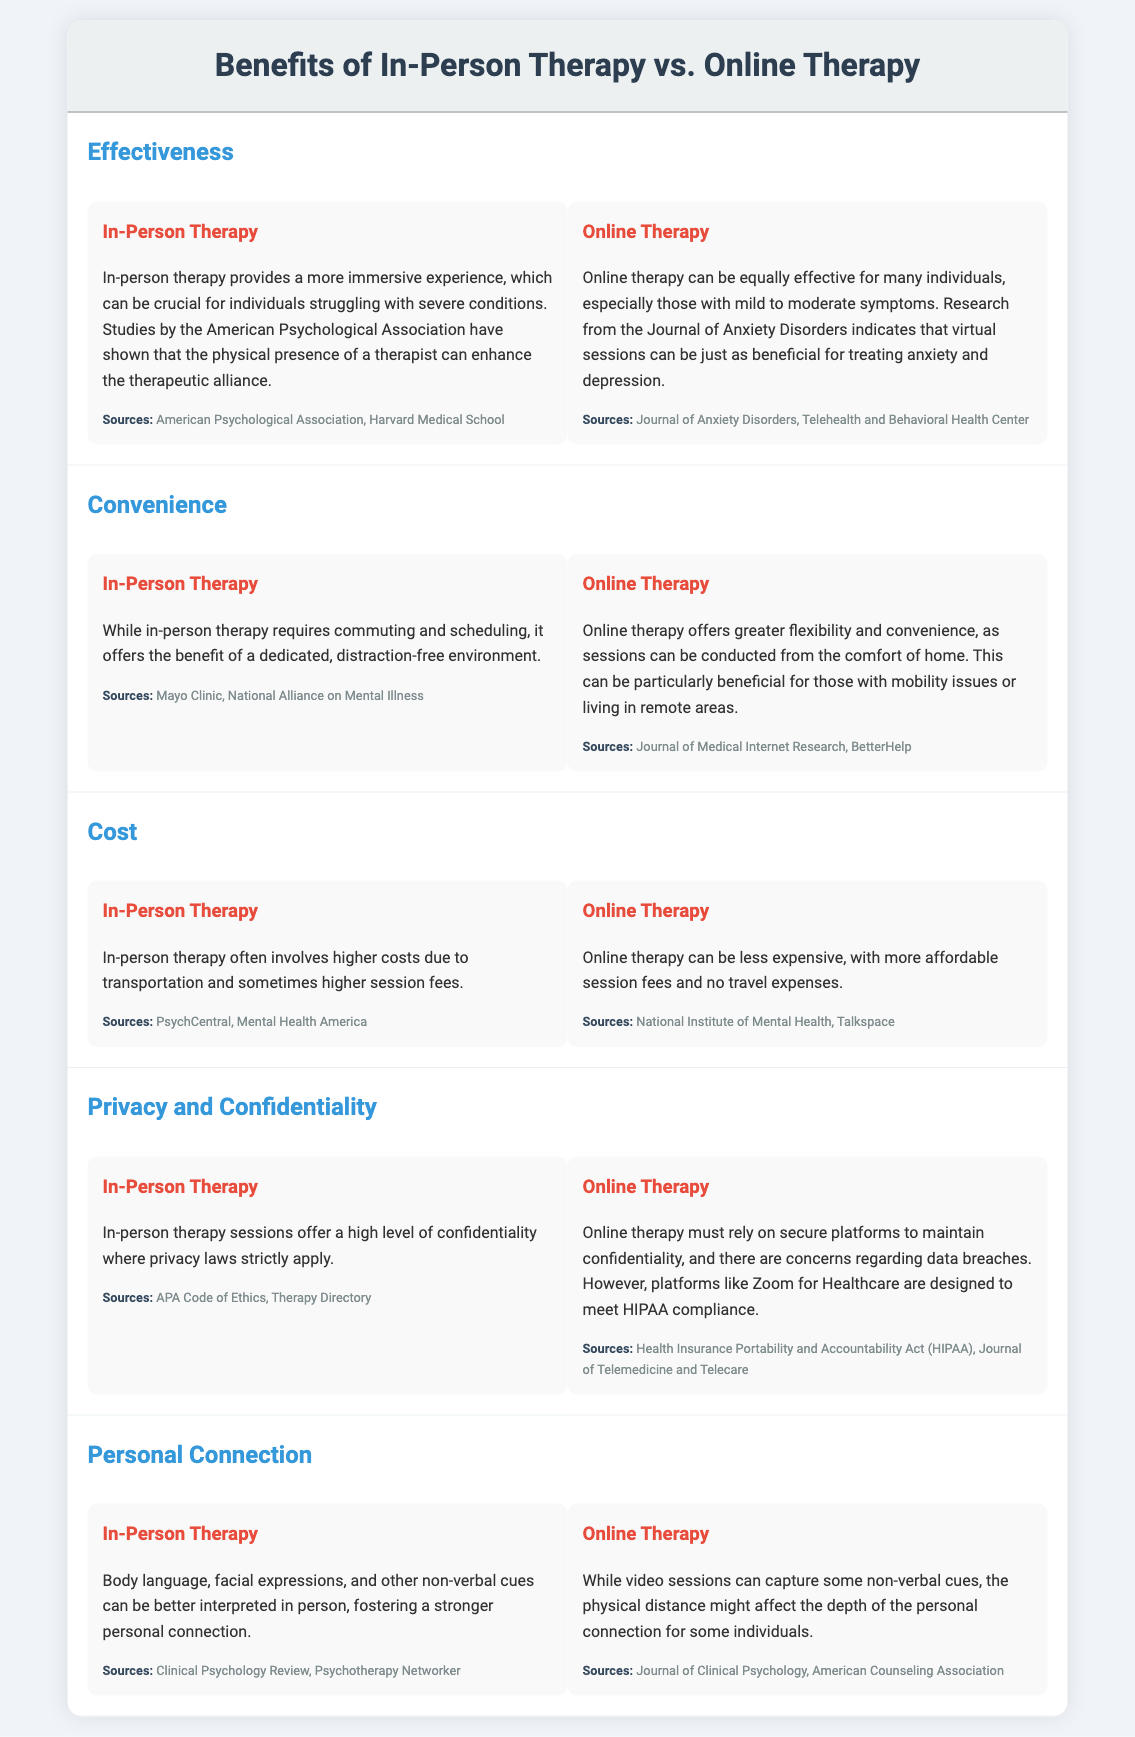What is one key benefit of in-person therapy? In-person therapy provides a more immersive experience, which can be crucial for individuals struggling with severe conditions.
Answer: immersive experience What research suggests that online therapy can be effective? Research from the Journal of Anxiety Disorders indicates that virtual sessions can be just as beneficial for treating anxiety and depression.
Answer: Journal of Anxiety Disorders What type of environment does in-person therapy offer? It offers the benefit of a dedicated, distraction-free environment.
Answer: distraction-free environment Which therapy is mentioned as often involving higher costs? In-person therapy often involves higher costs due to transportation and sometimes higher session fees.
Answer: In-person therapy What is a privacy concern related to online therapy? There are concerns regarding data breaches.
Answer: data breaches In which type of therapy are non-verbal cues better interpreted? Body language, facial expressions, and other non-verbal cues can be better interpreted in person.
Answer: in-person therapy Which therapy offers greater flexibility and convenience? Online therapy offers greater flexibility and convenience, as sessions can be conducted from the comfort of home.
Answer: Online therapy What primary source mentions the confidentiality of in-person therapy sessions? APA Code of Ethics
Answer: APA Code of Ethics Which therapy is generally less expensive? Online therapy can be less expensive, with more affordable session fees and no travel expenses.
Answer: Online therapy 